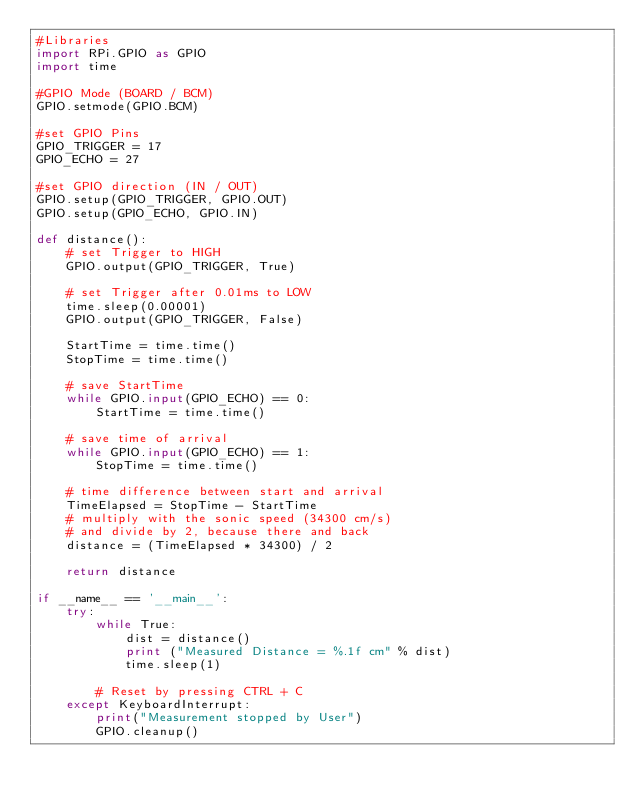<code> <loc_0><loc_0><loc_500><loc_500><_Python_>#Libraries
import RPi.GPIO as GPIO
import time
 
#GPIO Mode (BOARD / BCM)
GPIO.setmode(GPIO.BCM)

#set GPIO Pins
GPIO_TRIGGER = 17
GPIO_ECHO = 27
 
#set GPIO direction (IN / OUT)
GPIO.setup(GPIO_TRIGGER, GPIO.OUT)
GPIO.setup(GPIO_ECHO, GPIO.IN)
 
def distance():
    # set Trigger to HIGH
    GPIO.output(GPIO_TRIGGER, True)
 
    # set Trigger after 0.01ms to LOW
    time.sleep(0.00001)
    GPIO.output(GPIO_TRIGGER, False)
 
    StartTime = time.time()
    StopTime = time.time()
 
    # save StartTime
    while GPIO.input(GPIO_ECHO) == 0:
        StartTime = time.time()
 
    # save time of arrival
    while GPIO.input(GPIO_ECHO) == 1:
        StopTime = time.time()
 
    # time difference between start and arrival
    TimeElapsed = StopTime - StartTime
    # multiply with the sonic speed (34300 cm/s)
    # and divide by 2, because there and back
    distance = (TimeElapsed * 34300) / 2
 
    return distance
 
if __name__ == '__main__':
    try:
        while True:
            dist = distance()
            print ("Measured Distance = %.1f cm" % dist)
            time.sleep(1)
 
        # Reset by pressing CTRL + C
    except KeyboardInterrupt:
        print("Measurement stopped by User")
        GPIO.cleanup()
</code> 